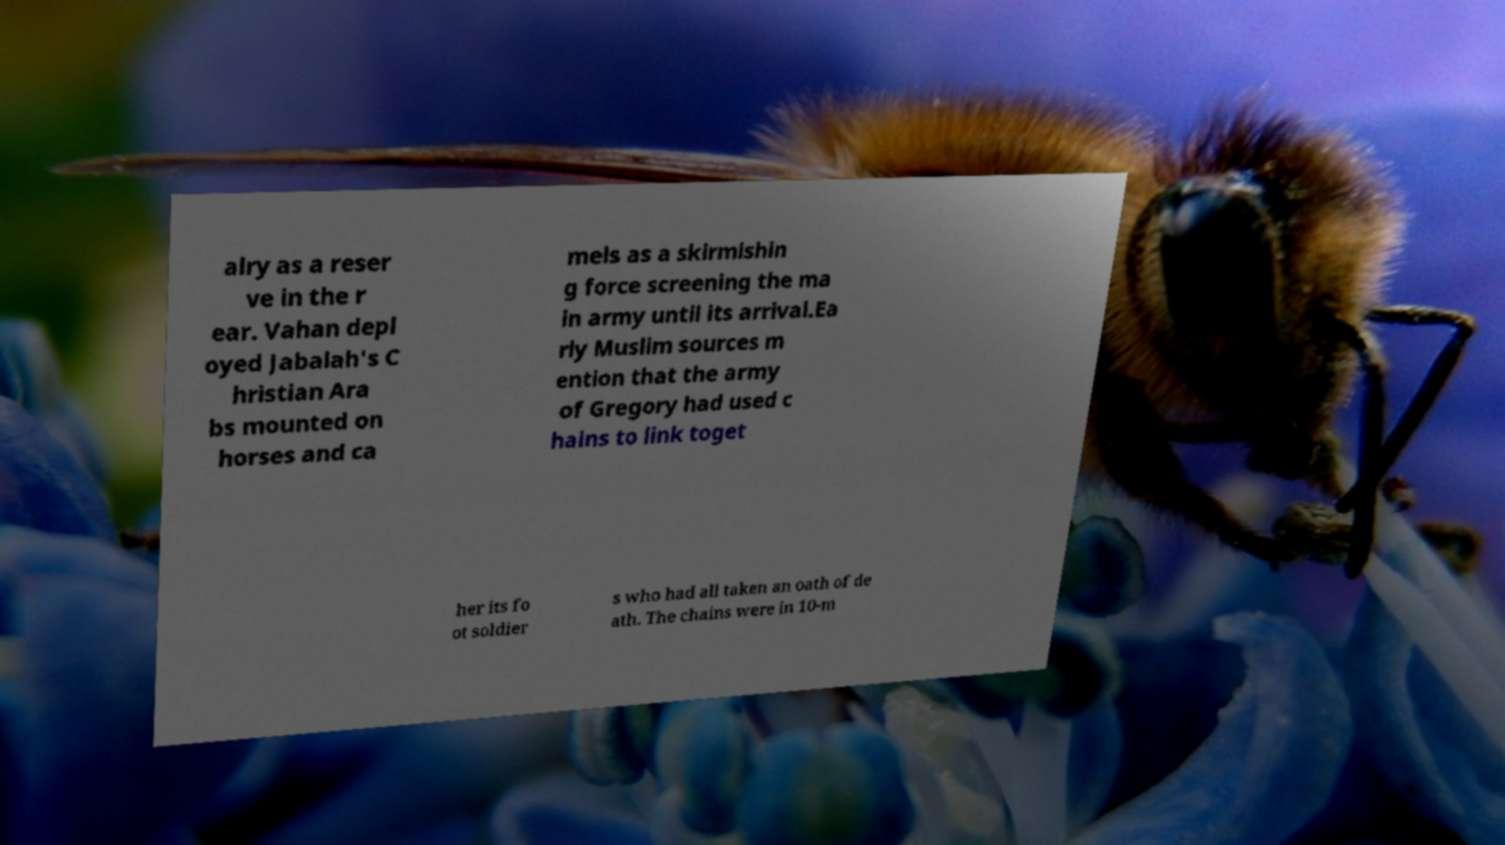Please read and relay the text visible in this image. What does it say? alry as a reser ve in the r ear. Vahan depl oyed Jabalah's C hristian Ara bs mounted on horses and ca mels as a skirmishin g force screening the ma in army until its arrival.Ea rly Muslim sources m ention that the army of Gregory had used c hains to link toget her its fo ot soldier s who had all taken an oath of de ath. The chains were in 10-m 